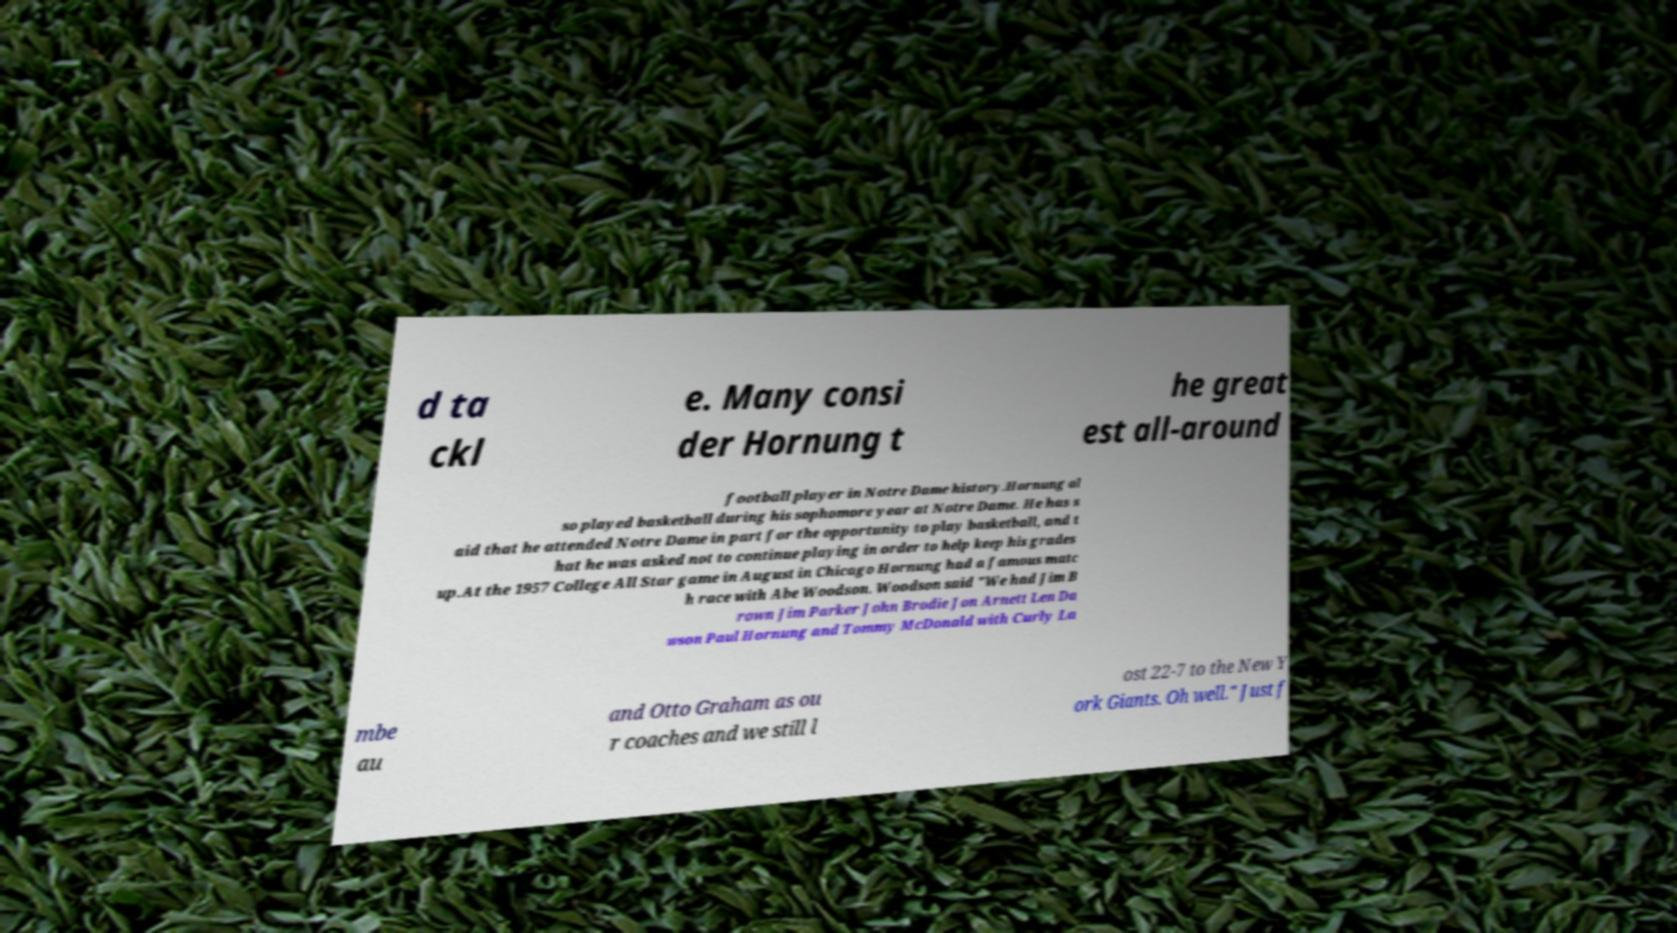Please identify and transcribe the text found in this image. d ta ckl e. Many consi der Hornung t he great est all-around football player in Notre Dame history.Hornung al so played basketball during his sophomore year at Notre Dame. He has s aid that he attended Notre Dame in part for the opportunity to play basketball, and t hat he was asked not to continue playing in order to help keep his grades up.At the 1957 College All Star game in August in Chicago Hornung had a famous matc h race with Abe Woodson. Woodson said "We had Jim B rown Jim Parker John Brodie Jon Arnett Len Da wson Paul Hornung and Tommy McDonald with Curly La mbe au and Otto Graham as ou r coaches and we still l ost 22-7 to the New Y ork Giants. Oh well." Just f 